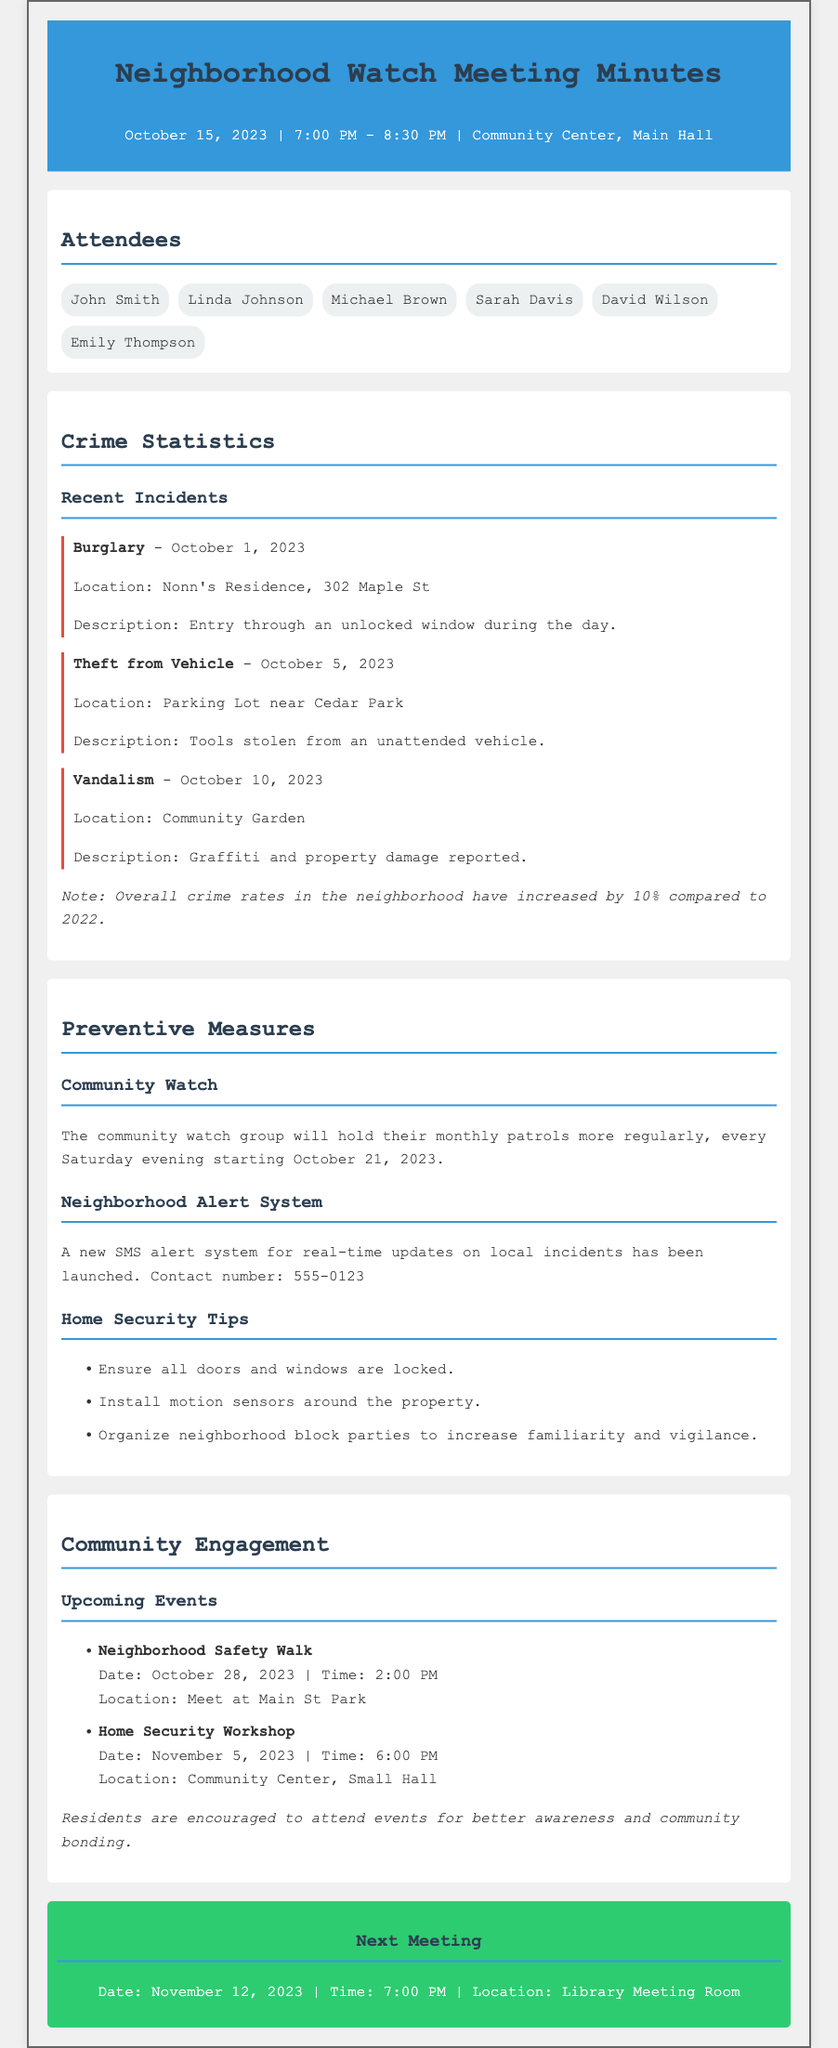What date did the neighborhood watch meeting take place? The meeting was held on October 15, 2023, as stated in the header.
Answer: October 15, 2023 How often will the community watch patrols occur? The document states that patrols will take place every Saturday evening.
Answer: Every Saturday evening What crime occurred at Nonn's Residence? The crime listed is burglary, according to the statistics section.
Answer: Burglary How many incidents of theft from vehicles were reported? The document lists one incident of theft from a vehicle during the meeting.
Answer: One What is the contact number for the neighborhood alert system? The document explicitly provides this information, stating the number is 555-0123.
Answer: 555-0123 What is the increase in overall crime rates compared to 2022? The document notes that crime rates have increased by 10%, reflecting this change.
Answer: 10% What is the date and time of the next neighborhood watch meeting? According to the next meeting section, the next meeting is scheduled for November 12, 2023, at 7 PM.
Answer: November 12, 2023, 7 PM Where is the upcoming home security workshop taking place? The document specifies the location as the Community Center, Small Hall.
Answer: Community Center, Small Hall 